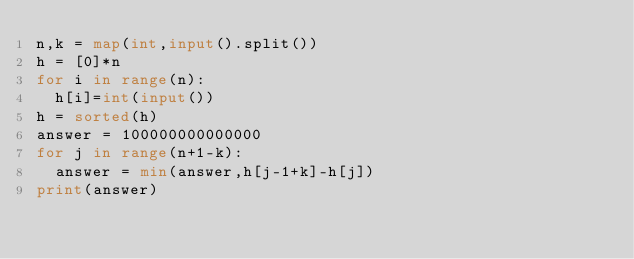<code> <loc_0><loc_0><loc_500><loc_500><_Python_>n,k = map(int,input().split())
h = [0]*n
for i in range(n):
  h[i]=int(input())
h = sorted(h)
answer = 100000000000000
for j in range(n+1-k):
  answer = min(answer,h[j-1+k]-h[j])
print(answer)</code> 